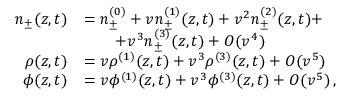<formula> <loc_0><loc_0><loc_500><loc_500>\begin{array} { r l } { n _ { \pm } ( z , t ) } & { = n _ { \pm } ^ { ( 0 ) } + v n _ { \pm } ^ { ( 1 ) } ( z , t ) + v ^ { 2 } n _ { \pm } ^ { ( 2 ) } ( z , t ) + } \\ & { \quad + v ^ { 3 } n _ { \pm } ^ { ( 3 ) } ( z , t ) + O ( v ^ { 4 } ) } \\ { \rho ( z , t ) } & { = v \rho ^ { ( 1 ) } ( z , t ) + v ^ { 3 } \rho ^ { ( 3 ) } ( z , t ) + O ( v ^ { 5 } ) } \\ { \phi ( z , t ) } & { = v \phi ^ { ( 1 ) } ( z , t ) + v ^ { 3 } \phi ^ { ( 3 ) } ( z , t ) + O ( v ^ { 5 } ) \, , } \end{array}</formula> 